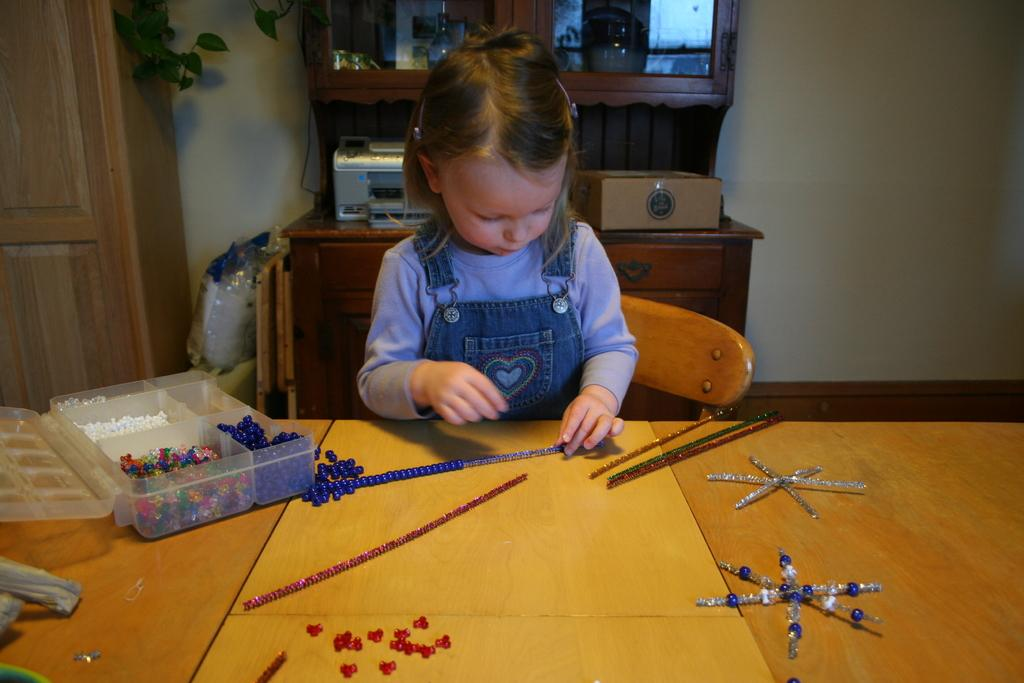What type of structure is present in the image? There is a wall in the image. What piece of furniture can be seen in the image? There is a table in the image. What other type of furniture is present in the image? There is a chair in the image. Who is present in the image? There is a girl standing in the image. What type of debt is the girl holding in the image? There is no debt present in the image; it features a girl standing near a wall, table, and chair. How does the girl twist her body in the image? The girl is not twisting her body in the image; she is standing still. 